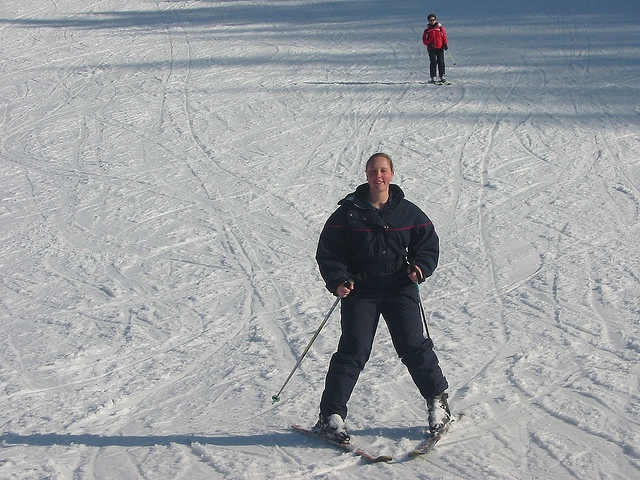Describe the objects in this image and their specific colors. I can see people in darkgray, black, and gray tones, skis in darkgray, gray, black, and darkblue tones, and skis in darkgray, gray, black, and lightgray tones in this image. 